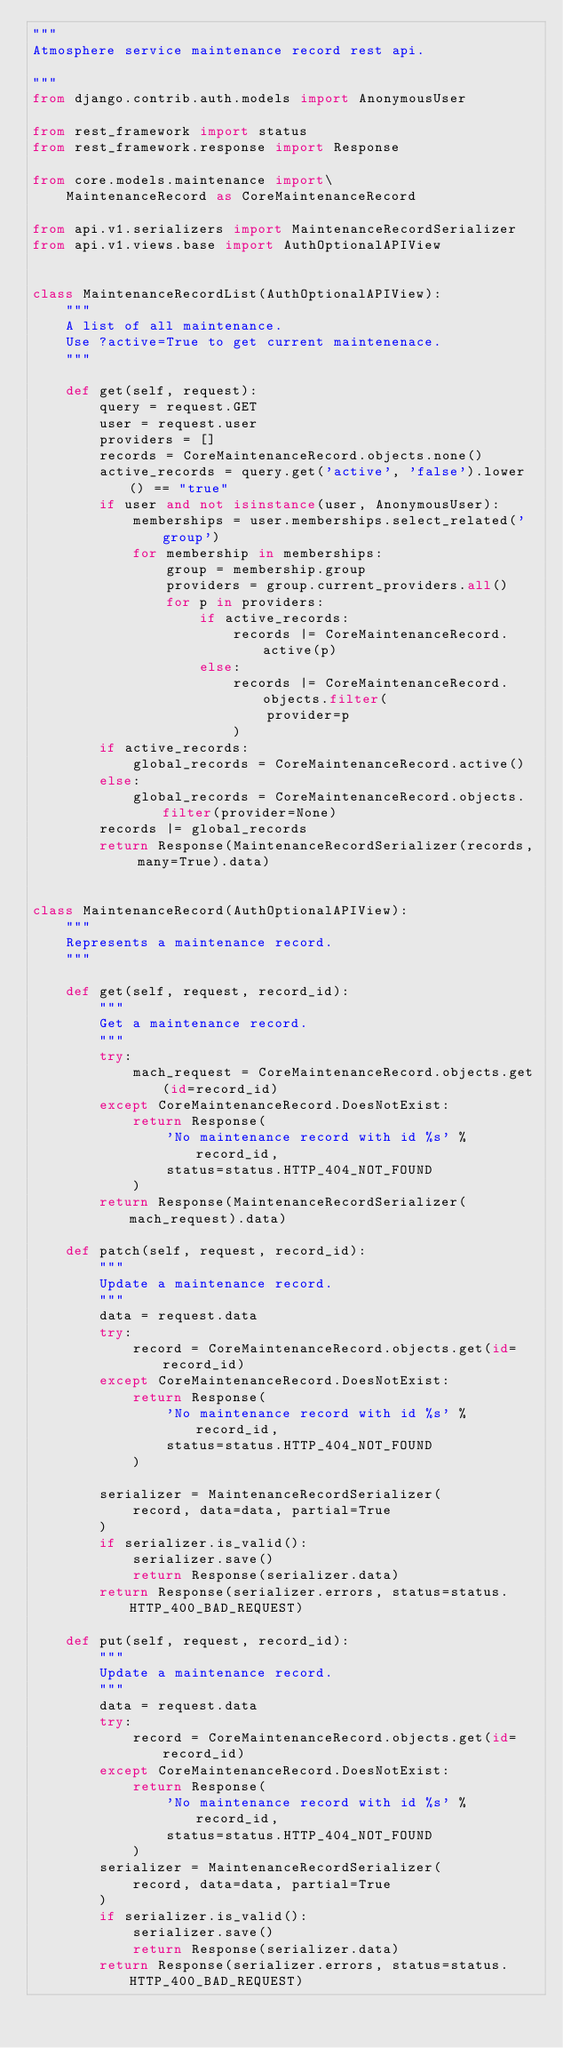<code> <loc_0><loc_0><loc_500><loc_500><_Python_>"""
Atmosphere service maintenance record rest api.

"""
from django.contrib.auth.models import AnonymousUser

from rest_framework import status
from rest_framework.response import Response

from core.models.maintenance import\
    MaintenanceRecord as CoreMaintenanceRecord

from api.v1.serializers import MaintenanceRecordSerializer
from api.v1.views.base import AuthOptionalAPIView


class MaintenanceRecordList(AuthOptionalAPIView):
    """
    A list of all maintenance.
    Use ?active=True to get current maintenenace.
    """

    def get(self, request):
        query = request.GET
        user = request.user
        providers = []
        records = CoreMaintenanceRecord.objects.none()
        active_records = query.get('active', 'false').lower() == "true"
        if user and not isinstance(user, AnonymousUser):
            memberships = user.memberships.select_related('group')
            for membership in memberships:
                group = membership.group
                providers = group.current_providers.all()
                for p in providers:
                    if active_records:
                        records |= CoreMaintenanceRecord.active(p)
                    else:
                        records |= CoreMaintenanceRecord.objects.filter(
                            provider=p
                        )
        if active_records:
            global_records = CoreMaintenanceRecord.active()
        else:
            global_records = CoreMaintenanceRecord.objects.filter(provider=None)
        records |= global_records
        return Response(MaintenanceRecordSerializer(records, many=True).data)


class MaintenanceRecord(AuthOptionalAPIView):
    """
    Represents a maintenance record.
    """

    def get(self, request, record_id):
        """
        Get a maintenance record.
        """
        try:
            mach_request = CoreMaintenanceRecord.objects.get(id=record_id)
        except CoreMaintenanceRecord.DoesNotExist:
            return Response(
                'No maintenance record with id %s' % record_id,
                status=status.HTTP_404_NOT_FOUND
            )
        return Response(MaintenanceRecordSerializer(mach_request).data)

    def patch(self, request, record_id):
        """
        Update a maintenance record.
        """
        data = request.data
        try:
            record = CoreMaintenanceRecord.objects.get(id=record_id)
        except CoreMaintenanceRecord.DoesNotExist:
            return Response(
                'No maintenance record with id %s' % record_id,
                status=status.HTTP_404_NOT_FOUND
            )

        serializer = MaintenanceRecordSerializer(
            record, data=data, partial=True
        )
        if serializer.is_valid():
            serializer.save()
            return Response(serializer.data)
        return Response(serializer.errors, status=status.HTTP_400_BAD_REQUEST)

    def put(self, request, record_id):
        """
        Update a maintenance record.
        """
        data = request.data
        try:
            record = CoreMaintenanceRecord.objects.get(id=record_id)
        except CoreMaintenanceRecord.DoesNotExist:
            return Response(
                'No maintenance record with id %s' % record_id,
                status=status.HTTP_404_NOT_FOUND
            )
        serializer = MaintenanceRecordSerializer(
            record, data=data, partial=True
        )
        if serializer.is_valid():
            serializer.save()
            return Response(serializer.data)
        return Response(serializer.errors, status=status.HTTP_400_BAD_REQUEST)
</code> 